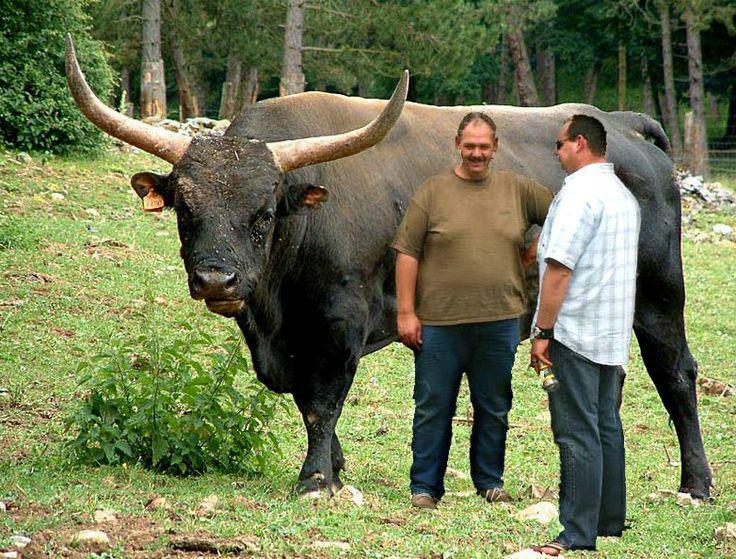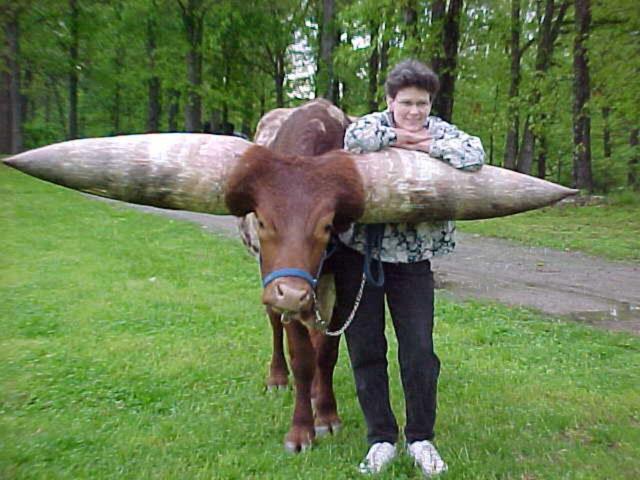The first image is the image on the left, the second image is the image on the right. For the images displayed, is the sentence "One image includes at least two cattle." factually correct? Answer yes or no. No. 